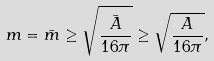Convert formula to latex. <formula><loc_0><loc_0><loc_500><loc_500>m = \bar { m } \geq \sqrt { \frac { \bar { A } } { 1 6 \pi } } \geq \sqrt { \frac { A } { 1 6 \pi } } ,</formula> 